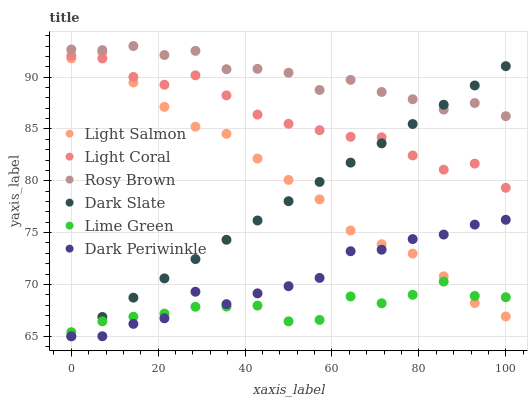Does Lime Green have the minimum area under the curve?
Answer yes or no. Yes. Does Rosy Brown have the maximum area under the curve?
Answer yes or no. Yes. Does Light Coral have the minimum area under the curve?
Answer yes or no. No. Does Light Coral have the maximum area under the curve?
Answer yes or no. No. Is Dark Slate the smoothest?
Answer yes or no. Yes. Is Rosy Brown the roughest?
Answer yes or no. Yes. Is Light Coral the smoothest?
Answer yes or no. No. Is Light Coral the roughest?
Answer yes or no. No. Does Dark Slate have the lowest value?
Answer yes or no. Yes. Does Light Coral have the lowest value?
Answer yes or no. No. Does Rosy Brown have the highest value?
Answer yes or no. Yes. Does Light Coral have the highest value?
Answer yes or no. No. Is Light Salmon less than Rosy Brown?
Answer yes or no. Yes. Is Rosy Brown greater than Dark Periwinkle?
Answer yes or no. Yes. Does Light Salmon intersect Dark Periwinkle?
Answer yes or no. Yes. Is Light Salmon less than Dark Periwinkle?
Answer yes or no. No. Is Light Salmon greater than Dark Periwinkle?
Answer yes or no. No. Does Light Salmon intersect Rosy Brown?
Answer yes or no. No. 